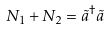Convert formula to latex. <formula><loc_0><loc_0><loc_500><loc_500>N _ { 1 } + N _ { 2 } = \tilde { a } ^ { \dag } \tilde { a }</formula> 